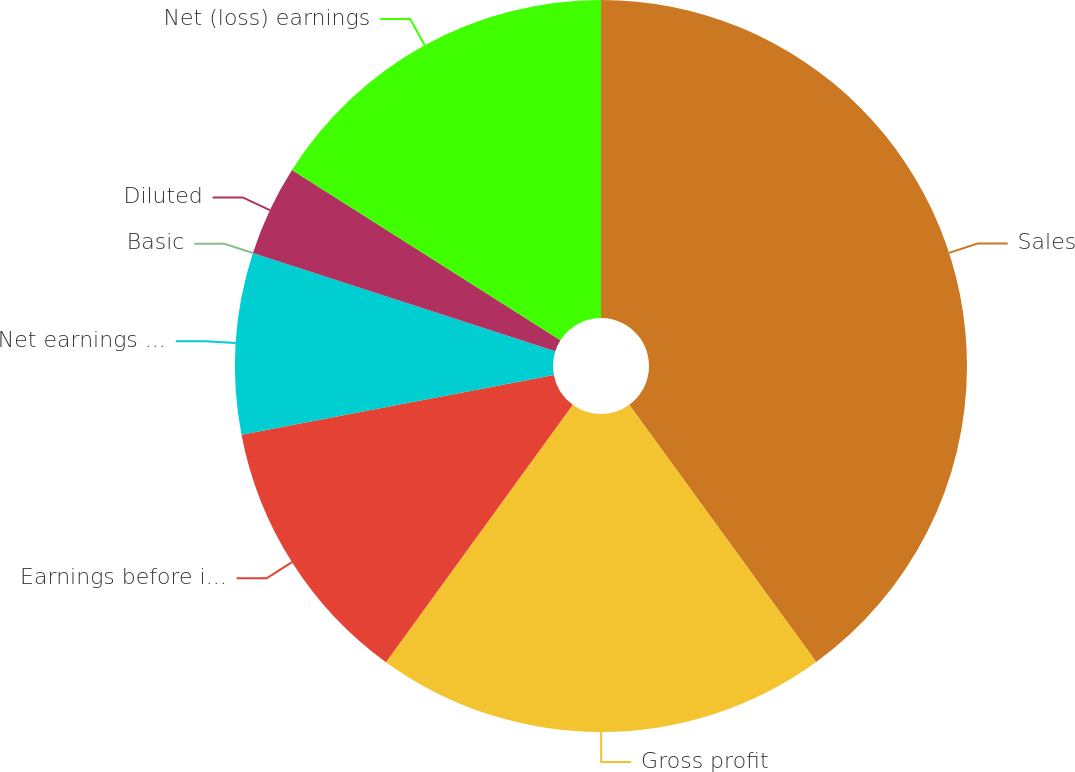<chart> <loc_0><loc_0><loc_500><loc_500><pie_chart><fcel>Sales<fcel>Gross profit<fcel>Earnings before income taxes<fcel>Net earnings attributable to<fcel>Basic<fcel>Diluted<fcel>Net (loss) earnings<nl><fcel>39.99%<fcel>20.0%<fcel>12.0%<fcel>8.0%<fcel>0.0%<fcel>4.0%<fcel>16.0%<nl></chart> 